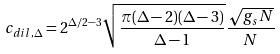<formula> <loc_0><loc_0><loc_500><loc_500>c _ { d i l , \Delta } = 2 ^ { \Delta / 2 - 3 } \sqrt { \frac { \pi ( \Delta - 2 ) ( \Delta - 3 ) } { \Delta - 1 } } \frac { \sqrt { g _ { s } N } } { N }</formula> 